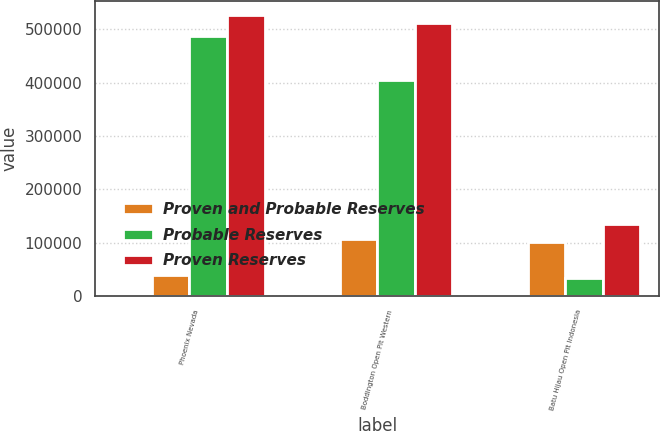Convert chart to OTSL. <chart><loc_0><loc_0><loc_500><loc_500><stacked_bar_chart><ecel><fcel>Phoenix Nevada<fcel>Boddington Open Pit Western<fcel>Batu Hijau Open Pit Indonesia<nl><fcel>nan<fcel>100<fcel>100<fcel>48.5<nl><fcel>Proven and Probable Reserves<fcel>39700<fcel>107400<fcel>101900<nl><fcel>Probable Reserves<fcel>487700<fcel>404300<fcel>32600<nl><fcel>Proven Reserves<fcel>527400<fcel>511700<fcel>134500<nl></chart> 